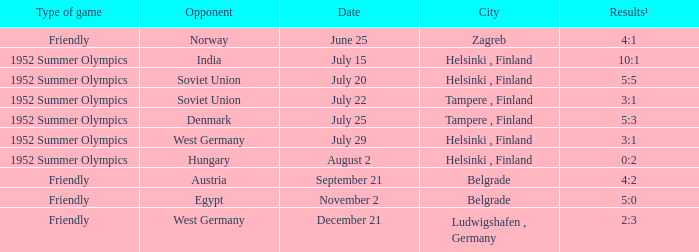What is the name of the City with December 21 as a Date? Ludwigshafen , Germany. 